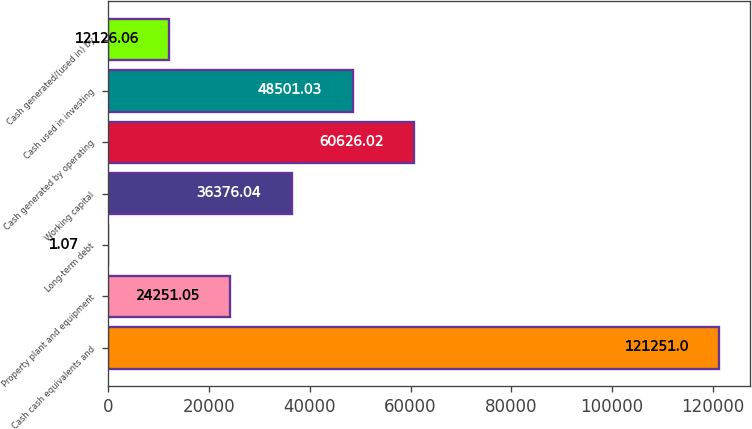Convert chart. <chart><loc_0><loc_0><loc_500><loc_500><bar_chart><fcel>Cash cash equivalents and<fcel>Property plant and equipment<fcel>Long-term debt<fcel>Working capital<fcel>Cash generated by operating<fcel>Cash used in investing<fcel>Cash generated/(used in) by<nl><fcel>121251<fcel>24251<fcel>1.07<fcel>36376<fcel>60626<fcel>48501<fcel>12126.1<nl></chart> 